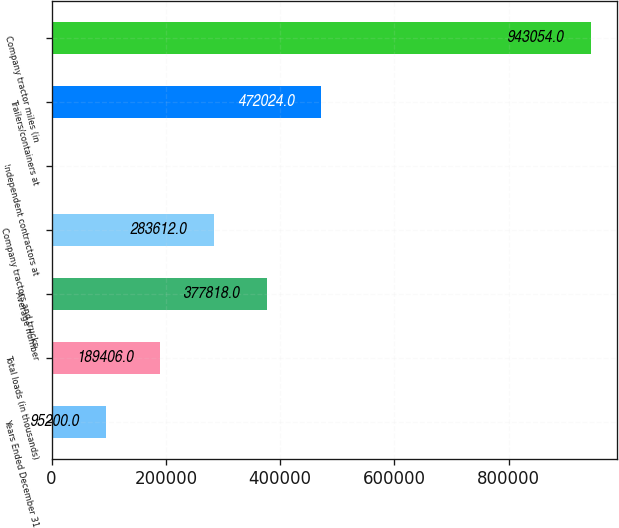<chart> <loc_0><loc_0><loc_500><loc_500><bar_chart><fcel>Years Ended December 31<fcel>Total loads (in thousands)<fcel>Average number<fcel>Company tractors and trucks<fcel>Independent contractors at<fcel>Trailers/containers at<fcel>Company tractor miles (in<nl><fcel>95200<fcel>189406<fcel>377818<fcel>283612<fcel>994<fcel>472024<fcel>943054<nl></chart> 